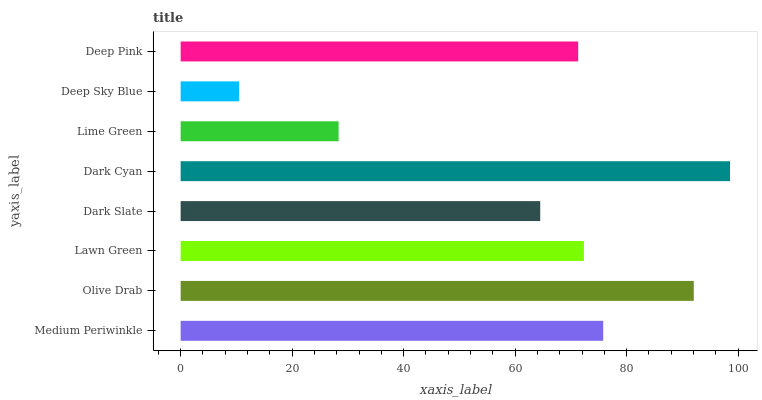Is Deep Sky Blue the minimum?
Answer yes or no. Yes. Is Dark Cyan the maximum?
Answer yes or no. Yes. Is Olive Drab the minimum?
Answer yes or no. No. Is Olive Drab the maximum?
Answer yes or no. No. Is Olive Drab greater than Medium Periwinkle?
Answer yes or no. Yes. Is Medium Periwinkle less than Olive Drab?
Answer yes or no. Yes. Is Medium Periwinkle greater than Olive Drab?
Answer yes or no. No. Is Olive Drab less than Medium Periwinkle?
Answer yes or no. No. Is Lawn Green the high median?
Answer yes or no. Yes. Is Deep Pink the low median?
Answer yes or no. Yes. Is Medium Periwinkle the high median?
Answer yes or no. No. Is Lawn Green the low median?
Answer yes or no. No. 